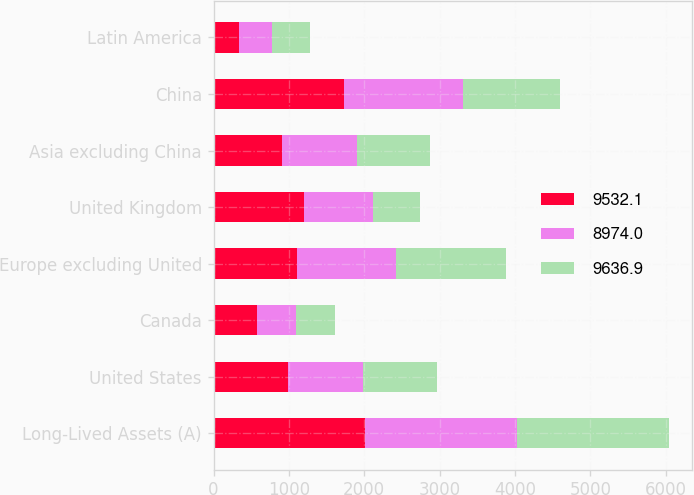<chart> <loc_0><loc_0><loc_500><loc_500><stacked_bar_chart><ecel><fcel>Long-Lived Assets (A)<fcel>United States<fcel>Canada<fcel>Europe excluding United<fcel>United Kingdom<fcel>Asia excluding China<fcel>China<fcel>Latin America<nl><fcel>9532.1<fcel>2015<fcel>989.9<fcel>577.4<fcel>1102.3<fcel>1196.3<fcel>914.2<fcel>1732.7<fcel>337.3<nl><fcel>8974<fcel>2014<fcel>989.9<fcel>518<fcel>1319.3<fcel>926.1<fcel>989.9<fcel>1582.7<fcel>440.1<nl><fcel>9636.9<fcel>2013<fcel>989.9<fcel>522.3<fcel>1456.2<fcel>612.6<fcel>962.3<fcel>1281.7<fcel>506.8<nl></chart> 